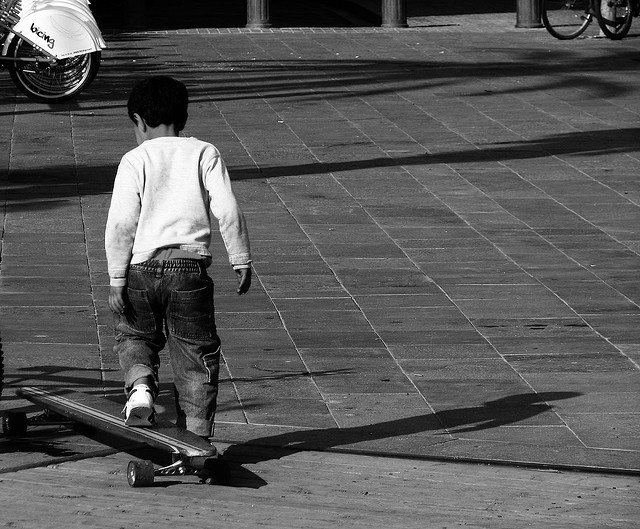Describe the objects in this image and their specific colors. I can see people in black, white, gray, and darkgray tones, bicycle in black, lightgray, gray, and darkgray tones, skateboard in black, gray, darkgray, and gainsboro tones, bicycle in black, gray, darkgray, and lightgray tones, and bicycle in black, gray, and lightgray tones in this image. 